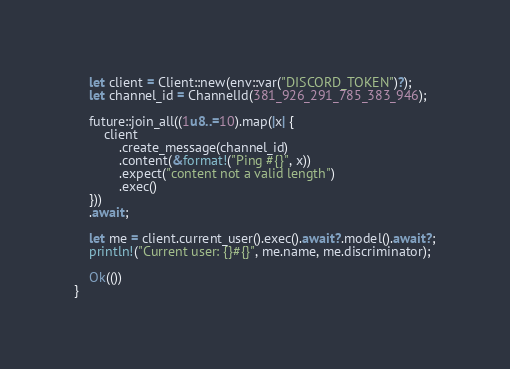Convert code to text. <code><loc_0><loc_0><loc_500><loc_500><_Rust_>
    let client = Client::new(env::var("DISCORD_TOKEN")?);
    let channel_id = ChannelId(381_926_291_785_383_946);

    future::join_all((1u8..=10).map(|x| {
        client
            .create_message(channel_id)
            .content(&format!("Ping #{}", x))
            .expect("content not a valid length")
            .exec()
    }))
    .await;

    let me = client.current_user().exec().await?.model().await?;
    println!("Current user: {}#{}", me.name, me.discriminator);

    Ok(())
}
</code> 